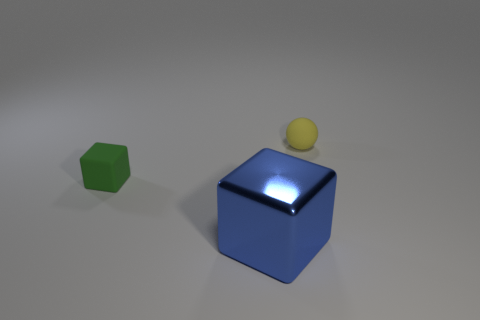What size is the blue metallic cube?
Ensure brevity in your answer.  Large. Are there more things left of the big shiny block than tiny matte balls in front of the yellow matte sphere?
Keep it short and to the point. Yes. There is a thing on the right side of the large blue shiny cube; what number of small objects are behind it?
Your answer should be compact. 0. There is a tiny object to the right of the small rubber cube; is its shape the same as the blue thing?
Your response must be concise. No. What is the material of the other object that is the same shape as the green rubber thing?
Give a very brief answer. Metal. What number of matte objects are the same size as the matte cube?
Give a very brief answer. 1. What is the color of the object that is both in front of the small yellow matte ball and behind the blue shiny thing?
Ensure brevity in your answer.  Green. Is the number of large green metal cylinders less than the number of green matte cubes?
Your answer should be compact. Yes. Is the number of green matte blocks right of the tiny green thing the same as the number of green cubes that are behind the yellow ball?
Offer a terse response. Yes. How many blue things are the same shape as the small green matte thing?
Provide a short and direct response. 1. 